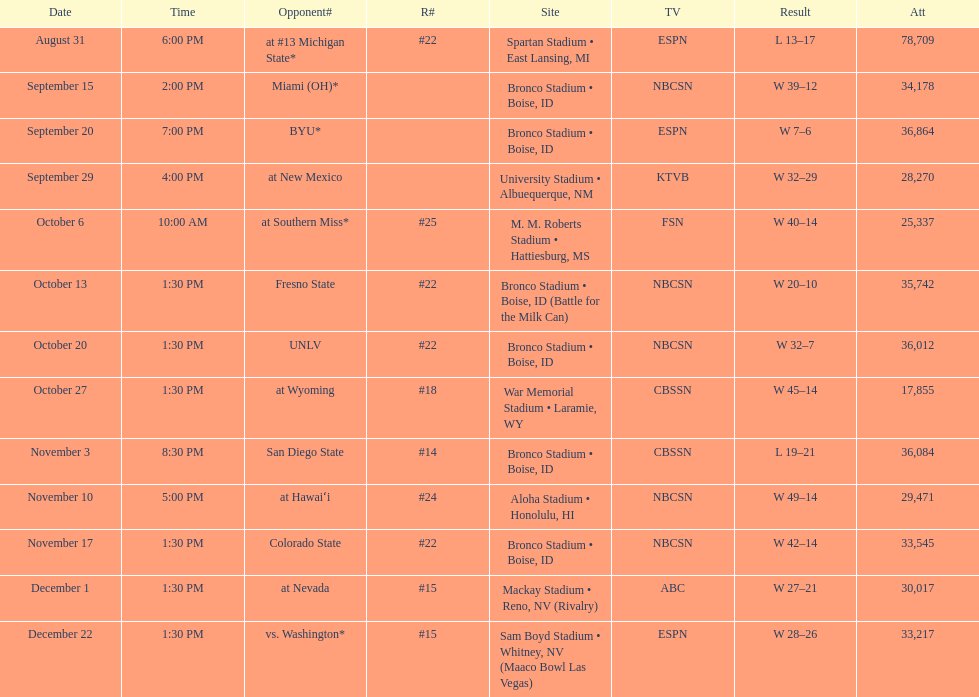Which team has the highest rank among those listed? San Diego State. I'm looking to parse the entire table for insights. Could you assist me with that? {'header': ['Date', 'Time', 'Opponent#', 'R#', 'Site', 'TV', 'Result', 'Att'], 'rows': [['August 31', '6:00 PM', 'at\xa0#13\xa0Michigan State*', '#22', 'Spartan Stadium • East Lansing, MI', 'ESPN', 'L\xa013–17', '78,709'], ['September 15', '2:00 PM', 'Miami (OH)*', '', 'Bronco Stadium • Boise, ID', 'NBCSN', 'W\xa039–12', '34,178'], ['September 20', '7:00 PM', 'BYU*', '', 'Bronco Stadium • Boise, ID', 'ESPN', 'W\xa07–6', '36,864'], ['September 29', '4:00 PM', 'at\xa0New Mexico', '', 'University Stadium • Albuequerque, NM', 'KTVB', 'W\xa032–29', '28,270'], ['October 6', '10:00 AM', 'at\xa0Southern Miss*', '#25', 'M. M. Roberts Stadium • Hattiesburg, MS', 'FSN', 'W\xa040–14', '25,337'], ['October 13', '1:30 PM', 'Fresno State', '#22', 'Bronco Stadium • Boise, ID (Battle for the Milk Can)', 'NBCSN', 'W\xa020–10', '35,742'], ['October 20', '1:30 PM', 'UNLV', '#22', 'Bronco Stadium • Boise, ID', 'NBCSN', 'W\xa032–7', '36,012'], ['October 27', '1:30 PM', 'at\xa0Wyoming', '#18', 'War Memorial Stadium • Laramie, WY', 'CBSSN', 'W\xa045–14', '17,855'], ['November 3', '8:30 PM', 'San Diego State', '#14', 'Bronco Stadium • Boise, ID', 'CBSSN', 'L\xa019–21', '36,084'], ['November 10', '5:00 PM', 'at\xa0Hawaiʻi', '#24', 'Aloha Stadium • Honolulu, HI', 'NBCSN', 'W\xa049–14', '29,471'], ['November 17', '1:30 PM', 'Colorado State', '#22', 'Bronco Stadium • Boise, ID', 'NBCSN', 'W\xa042–14', '33,545'], ['December 1', '1:30 PM', 'at\xa0Nevada', '#15', 'Mackay Stadium • Reno, NV (Rivalry)', 'ABC', 'W\xa027–21', '30,017'], ['December 22', '1:30 PM', 'vs.\xa0Washington*', '#15', 'Sam Boyd Stadium • Whitney, NV (Maaco Bowl Las Vegas)', 'ESPN', 'W\xa028–26', '33,217']]} 